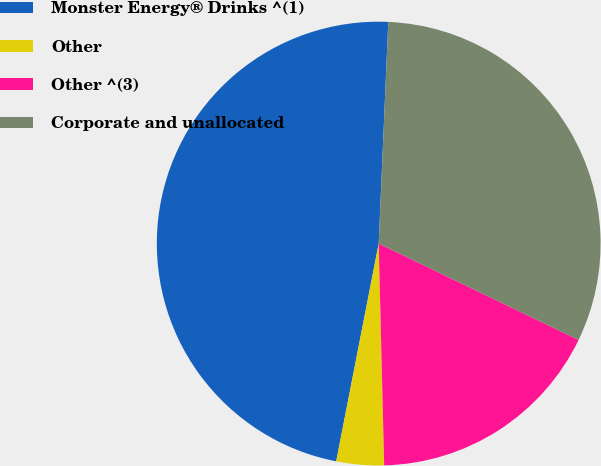<chart> <loc_0><loc_0><loc_500><loc_500><pie_chart><fcel>Monster Energy® Drinks ^(1)<fcel>Other<fcel>Other ^(3)<fcel>Corporate and unallocated<nl><fcel>47.62%<fcel>3.46%<fcel>17.46%<fcel>31.46%<nl></chart> 